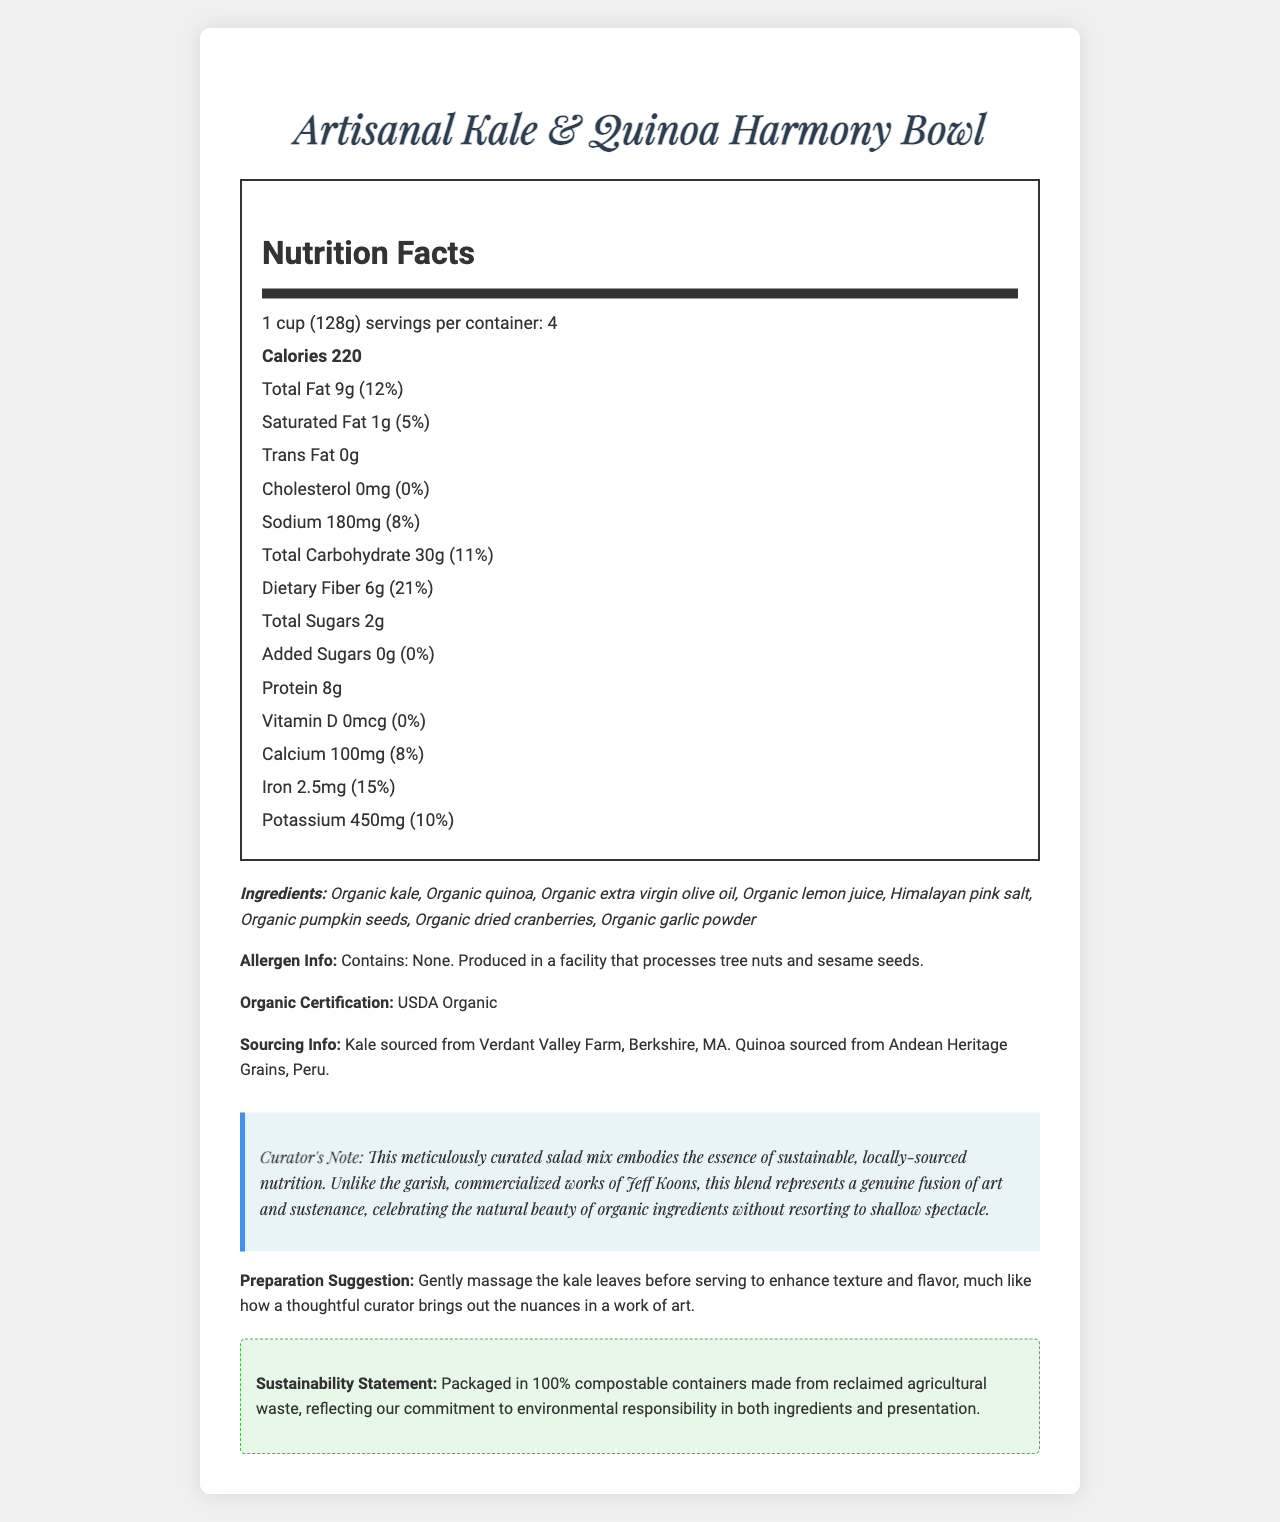What is the serving size of the Artisanal Kale & Quinoa Harmony Bowl? The serving size is clearly stated at the beginning of the Nutrition Facts section.
Answer: 1 cup (128g) How many calories are in each serving? The number of calories per serving is listed as 220 in the nutrition label.
Answer: 220 What is the percentage daily value of dietary fiber? The daily value percentage for dietary fiber is shown as 21%.
Answer: 21% Does the product contain any trans fat? The trans fat content is listed as 0g, indicating there is no trans fat in the product.
Answer: No What is the sodium content per serving? The sodium content is listed as 180mg per serving.
Answer: 180mg How much protein is in each serving of the salad? The amount of protein per serving is stated as 8g.
Answer: 8g List the first three ingredients of the salad mix. These ingredients are listed at the beginning of the ingredients list.
Answer: Organic kale, Organic quinoa, Organic extra virgin olive oil Which of the following statements is true about the added sugars in the product?: A. Contains 5g of added sugars B. Contains 2g of added sugars C. Contains 0g of added sugars The added sugars content is listed as 0g, making option C correct.
Answer: C How much calcium per serving does the salad contain?: A. 50mg B. 75mg C. 100mg D. 120mg The calcium content per serving is 100mg, making option C the correct answer.
Answer: C Is this product USDA Organic certified? The document clearly states that the product has USDA Organic certification.
Answer: Yes Was the quinoa sourced locally? The quinoa is sourced from Andean Heritage Grains, Peru, which is not local.
Answer: No Summarize the main idea of the document. The document offers a comprehensive overview of the product, including nutritional values, certifications, sources of ingredients, and additional notes on sustainability and preparation.
Answer: The document provides detailed nutritional information about the Artisanal Kale & Quinoa Harmony Bowl, including its ingredients, allergen information, organic certification, and sourcing details. It highlights the product's sustainability and provides preparation suggestions. What is the founder's favorite artist? The document provides no information about the founder's favorite artist.
Answer: Cannot be determined 